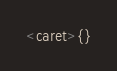Convert code to text. <code><loc_0><loc_0><loc_500><loc_500><_Awk_>
<caret>{}</code> 